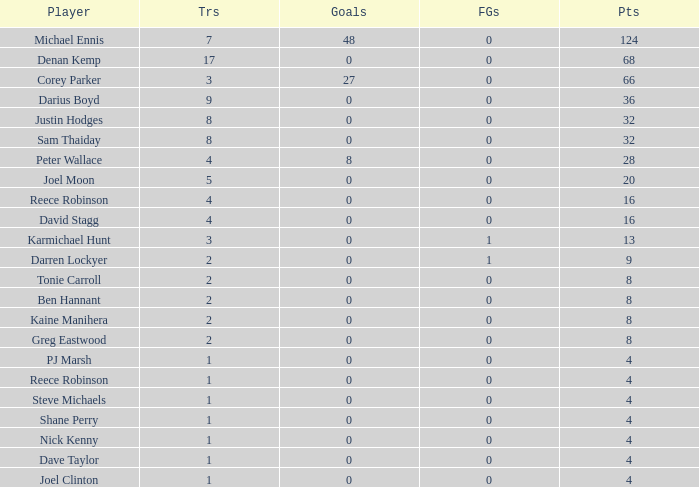How many points did the player with 2 tries and more than 0 field goals have? 9.0. 